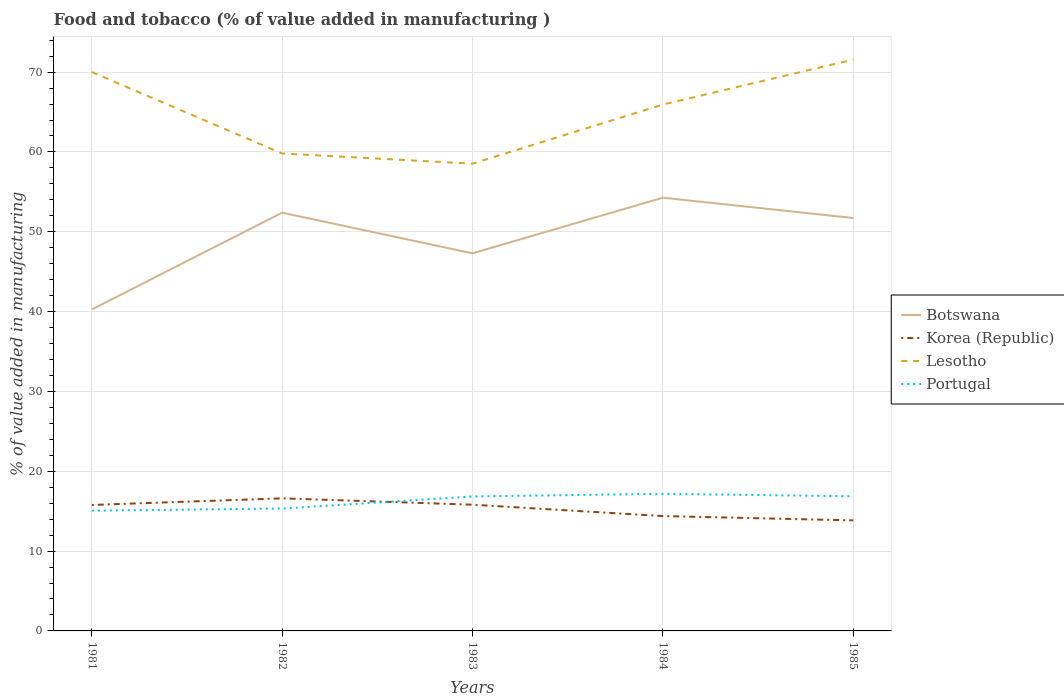Is the number of lines equal to the number of legend labels?
Keep it short and to the point. Yes. Across all years, what is the maximum value added in manufacturing food and tobacco in Portugal?
Offer a very short reply. 15.06. What is the total value added in manufacturing food and tobacco in Korea (Republic) in the graph?
Provide a succinct answer. 2.76. What is the difference between the highest and the second highest value added in manufacturing food and tobacco in Lesotho?
Your answer should be very brief. 13.03. What is the difference between the highest and the lowest value added in manufacturing food and tobacco in Botswana?
Give a very brief answer. 3. Is the value added in manufacturing food and tobacco in Korea (Republic) strictly greater than the value added in manufacturing food and tobacco in Botswana over the years?
Make the answer very short. Yes. Does the graph contain any zero values?
Give a very brief answer. No. Where does the legend appear in the graph?
Give a very brief answer. Center right. How many legend labels are there?
Give a very brief answer. 4. What is the title of the graph?
Make the answer very short. Food and tobacco (% of value added in manufacturing ). What is the label or title of the X-axis?
Keep it short and to the point. Years. What is the label or title of the Y-axis?
Give a very brief answer. % of value added in manufacturing. What is the % of value added in manufacturing of Botswana in 1981?
Provide a short and direct response. 40.27. What is the % of value added in manufacturing in Korea (Republic) in 1981?
Provide a short and direct response. 15.78. What is the % of value added in manufacturing of Lesotho in 1981?
Ensure brevity in your answer.  70.01. What is the % of value added in manufacturing of Portugal in 1981?
Offer a terse response. 15.06. What is the % of value added in manufacturing in Botswana in 1982?
Offer a very short reply. 52.39. What is the % of value added in manufacturing in Korea (Republic) in 1982?
Offer a very short reply. 16.61. What is the % of value added in manufacturing in Lesotho in 1982?
Provide a short and direct response. 59.81. What is the % of value added in manufacturing in Portugal in 1982?
Offer a terse response. 15.33. What is the % of value added in manufacturing of Botswana in 1983?
Keep it short and to the point. 47.3. What is the % of value added in manufacturing of Korea (Republic) in 1983?
Offer a terse response. 15.81. What is the % of value added in manufacturing of Lesotho in 1983?
Give a very brief answer. 58.53. What is the % of value added in manufacturing of Portugal in 1983?
Your answer should be compact. 16.84. What is the % of value added in manufacturing of Botswana in 1984?
Make the answer very short. 54.27. What is the % of value added in manufacturing in Korea (Republic) in 1984?
Provide a short and direct response. 14.39. What is the % of value added in manufacturing in Lesotho in 1984?
Your answer should be very brief. 65.93. What is the % of value added in manufacturing of Portugal in 1984?
Give a very brief answer. 17.17. What is the % of value added in manufacturing of Botswana in 1985?
Make the answer very short. 51.72. What is the % of value added in manufacturing in Korea (Republic) in 1985?
Provide a succinct answer. 13.85. What is the % of value added in manufacturing of Lesotho in 1985?
Provide a succinct answer. 71.56. What is the % of value added in manufacturing of Portugal in 1985?
Make the answer very short. 16.87. Across all years, what is the maximum % of value added in manufacturing in Botswana?
Your response must be concise. 54.27. Across all years, what is the maximum % of value added in manufacturing of Korea (Republic)?
Your response must be concise. 16.61. Across all years, what is the maximum % of value added in manufacturing in Lesotho?
Give a very brief answer. 71.56. Across all years, what is the maximum % of value added in manufacturing in Portugal?
Provide a short and direct response. 17.17. Across all years, what is the minimum % of value added in manufacturing in Botswana?
Provide a succinct answer. 40.27. Across all years, what is the minimum % of value added in manufacturing of Korea (Republic)?
Your answer should be compact. 13.85. Across all years, what is the minimum % of value added in manufacturing of Lesotho?
Provide a short and direct response. 58.53. Across all years, what is the minimum % of value added in manufacturing in Portugal?
Offer a very short reply. 15.06. What is the total % of value added in manufacturing of Botswana in the graph?
Provide a succinct answer. 245.95. What is the total % of value added in manufacturing in Korea (Republic) in the graph?
Provide a short and direct response. 76.43. What is the total % of value added in manufacturing of Lesotho in the graph?
Your response must be concise. 325.84. What is the total % of value added in manufacturing of Portugal in the graph?
Give a very brief answer. 81.27. What is the difference between the % of value added in manufacturing of Botswana in 1981 and that in 1982?
Provide a succinct answer. -12.13. What is the difference between the % of value added in manufacturing of Korea (Republic) in 1981 and that in 1982?
Provide a short and direct response. -0.83. What is the difference between the % of value added in manufacturing of Lesotho in 1981 and that in 1982?
Make the answer very short. 10.2. What is the difference between the % of value added in manufacturing in Portugal in 1981 and that in 1982?
Make the answer very short. -0.27. What is the difference between the % of value added in manufacturing in Botswana in 1981 and that in 1983?
Provide a short and direct response. -7.04. What is the difference between the % of value added in manufacturing in Korea (Republic) in 1981 and that in 1983?
Ensure brevity in your answer.  -0.03. What is the difference between the % of value added in manufacturing of Lesotho in 1981 and that in 1983?
Provide a succinct answer. 11.48. What is the difference between the % of value added in manufacturing of Portugal in 1981 and that in 1983?
Keep it short and to the point. -1.78. What is the difference between the % of value added in manufacturing in Botswana in 1981 and that in 1984?
Offer a terse response. -14. What is the difference between the % of value added in manufacturing of Korea (Republic) in 1981 and that in 1984?
Provide a short and direct response. 1.39. What is the difference between the % of value added in manufacturing in Lesotho in 1981 and that in 1984?
Offer a very short reply. 4.07. What is the difference between the % of value added in manufacturing in Portugal in 1981 and that in 1984?
Offer a very short reply. -2.11. What is the difference between the % of value added in manufacturing of Botswana in 1981 and that in 1985?
Provide a succinct answer. -11.46. What is the difference between the % of value added in manufacturing of Korea (Republic) in 1981 and that in 1985?
Your response must be concise. 1.93. What is the difference between the % of value added in manufacturing in Lesotho in 1981 and that in 1985?
Provide a succinct answer. -1.56. What is the difference between the % of value added in manufacturing in Portugal in 1981 and that in 1985?
Give a very brief answer. -1.81. What is the difference between the % of value added in manufacturing of Botswana in 1982 and that in 1983?
Your answer should be very brief. 5.09. What is the difference between the % of value added in manufacturing of Korea (Republic) in 1982 and that in 1983?
Give a very brief answer. 0.8. What is the difference between the % of value added in manufacturing in Lesotho in 1982 and that in 1983?
Provide a short and direct response. 1.28. What is the difference between the % of value added in manufacturing in Portugal in 1982 and that in 1983?
Your response must be concise. -1.51. What is the difference between the % of value added in manufacturing of Botswana in 1982 and that in 1984?
Make the answer very short. -1.88. What is the difference between the % of value added in manufacturing in Korea (Republic) in 1982 and that in 1984?
Your response must be concise. 2.22. What is the difference between the % of value added in manufacturing in Lesotho in 1982 and that in 1984?
Keep it short and to the point. -6.13. What is the difference between the % of value added in manufacturing of Portugal in 1982 and that in 1984?
Your answer should be very brief. -1.84. What is the difference between the % of value added in manufacturing of Botswana in 1982 and that in 1985?
Offer a terse response. 0.67. What is the difference between the % of value added in manufacturing in Korea (Republic) in 1982 and that in 1985?
Provide a short and direct response. 2.76. What is the difference between the % of value added in manufacturing in Lesotho in 1982 and that in 1985?
Provide a succinct answer. -11.76. What is the difference between the % of value added in manufacturing of Portugal in 1982 and that in 1985?
Provide a short and direct response. -1.54. What is the difference between the % of value added in manufacturing in Botswana in 1983 and that in 1984?
Your answer should be compact. -6.97. What is the difference between the % of value added in manufacturing of Korea (Republic) in 1983 and that in 1984?
Offer a very short reply. 1.43. What is the difference between the % of value added in manufacturing of Lesotho in 1983 and that in 1984?
Offer a terse response. -7.4. What is the difference between the % of value added in manufacturing of Portugal in 1983 and that in 1984?
Offer a very short reply. -0.33. What is the difference between the % of value added in manufacturing in Botswana in 1983 and that in 1985?
Offer a terse response. -4.42. What is the difference between the % of value added in manufacturing in Korea (Republic) in 1983 and that in 1985?
Your answer should be compact. 1.97. What is the difference between the % of value added in manufacturing of Lesotho in 1983 and that in 1985?
Offer a very short reply. -13.03. What is the difference between the % of value added in manufacturing in Portugal in 1983 and that in 1985?
Give a very brief answer. -0.02. What is the difference between the % of value added in manufacturing of Botswana in 1984 and that in 1985?
Keep it short and to the point. 2.54. What is the difference between the % of value added in manufacturing of Korea (Republic) in 1984 and that in 1985?
Provide a succinct answer. 0.54. What is the difference between the % of value added in manufacturing in Lesotho in 1984 and that in 1985?
Offer a terse response. -5.63. What is the difference between the % of value added in manufacturing in Portugal in 1984 and that in 1985?
Give a very brief answer. 0.31. What is the difference between the % of value added in manufacturing in Botswana in 1981 and the % of value added in manufacturing in Korea (Republic) in 1982?
Your response must be concise. 23.66. What is the difference between the % of value added in manufacturing of Botswana in 1981 and the % of value added in manufacturing of Lesotho in 1982?
Offer a very short reply. -19.54. What is the difference between the % of value added in manufacturing of Botswana in 1981 and the % of value added in manufacturing of Portugal in 1982?
Make the answer very short. 24.94. What is the difference between the % of value added in manufacturing of Korea (Republic) in 1981 and the % of value added in manufacturing of Lesotho in 1982?
Keep it short and to the point. -44.03. What is the difference between the % of value added in manufacturing in Korea (Republic) in 1981 and the % of value added in manufacturing in Portugal in 1982?
Keep it short and to the point. 0.45. What is the difference between the % of value added in manufacturing in Lesotho in 1981 and the % of value added in manufacturing in Portugal in 1982?
Ensure brevity in your answer.  54.68. What is the difference between the % of value added in manufacturing in Botswana in 1981 and the % of value added in manufacturing in Korea (Republic) in 1983?
Give a very brief answer. 24.45. What is the difference between the % of value added in manufacturing in Botswana in 1981 and the % of value added in manufacturing in Lesotho in 1983?
Make the answer very short. -18.26. What is the difference between the % of value added in manufacturing in Botswana in 1981 and the % of value added in manufacturing in Portugal in 1983?
Provide a short and direct response. 23.42. What is the difference between the % of value added in manufacturing in Korea (Republic) in 1981 and the % of value added in manufacturing in Lesotho in 1983?
Provide a succinct answer. -42.75. What is the difference between the % of value added in manufacturing of Korea (Republic) in 1981 and the % of value added in manufacturing of Portugal in 1983?
Your answer should be compact. -1.07. What is the difference between the % of value added in manufacturing of Lesotho in 1981 and the % of value added in manufacturing of Portugal in 1983?
Ensure brevity in your answer.  53.16. What is the difference between the % of value added in manufacturing of Botswana in 1981 and the % of value added in manufacturing of Korea (Republic) in 1984?
Ensure brevity in your answer.  25.88. What is the difference between the % of value added in manufacturing in Botswana in 1981 and the % of value added in manufacturing in Lesotho in 1984?
Provide a succinct answer. -25.67. What is the difference between the % of value added in manufacturing of Botswana in 1981 and the % of value added in manufacturing of Portugal in 1984?
Offer a terse response. 23.09. What is the difference between the % of value added in manufacturing in Korea (Republic) in 1981 and the % of value added in manufacturing in Lesotho in 1984?
Your answer should be very brief. -50.16. What is the difference between the % of value added in manufacturing in Korea (Republic) in 1981 and the % of value added in manufacturing in Portugal in 1984?
Provide a succinct answer. -1.4. What is the difference between the % of value added in manufacturing of Lesotho in 1981 and the % of value added in manufacturing of Portugal in 1984?
Provide a short and direct response. 52.83. What is the difference between the % of value added in manufacturing in Botswana in 1981 and the % of value added in manufacturing in Korea (Republic) in 1985?
Your response must be concise. 26.42. What is the difference between the % of value added in manufacturing in Botswana in 1981 and the % of value added in manufacturing in Lesotho in 1985?
Keep it short and to the point. -31.3. What is the difference between the % of value added in manufacturing of Botswana in 1981 and the % of value added in manufacturing of Portugal in 1985?
Provide a short and direct response. 23.4. What is the difference between the % of value added in manufacturing of Korea (Republic) in 1981 and the % of value added in manufacturing of Lesotho in 1985?
Offer a terse response. -55.79. What is the difference between the % of value added in manufacturing of Korea (Republic) in 1981 and the % of value added in manufacturing of Portugal in 1985?
Keep it short and to the point. -1.09. What is the difference between the % of value added in manufacturing in Lesotho in 1981 and the % of value added in manufacturing in Portugal in 1985?
Provide a short and direct response. 53.14. What is the difference between the % of value added in manufacturing of Botswana in 1982 and the % of value added in manufacturing of Korea (Republic) in 1983?
Offer a very short reply. 36.58. What is the difference between the % of value added in manufacturing of Botswana in 1982 and the % of value added in manufacturing of Lesotho in 1983?
Your response must be concise. -6.14. What is the difference between the % of value added in manufacturing in Botswana in 1982 and the % of value added in manufacturing in Portugal in 1983?
Ensure brevity in your answer.  35.55. What is the difference between the % of value added in manufacturing in Korea (Republic) in 1982 and the % of value added in manufacturing in Lesotho in 1983?
Offer a terse response. -41.92. What is the difference between the % of value added in manufacturing of Korea (Republic) in 1982 and the % of value added in manufacturing of Portugal in 1983?
Give a very brief answer. -0.23. What is the difference between the % of value added in manufacturing in Lesotho in 1982 and the % of value added in manufacturing in Portugal in 1983?
Keep it short and to the point. 42.96. What is the difference between the % of value added in manufacturing of Botswana in 1982 and the % of value added in manufacturing of Korea (Republic) in 1984?
Provide a succinct answer. 38.01. What is the difference between the % of value added in manufacturing of Botswana in 1982 and the % of value added in manufacturing of Lesotho in 1984?
Provide a succinct answer. -13.54. What is the difference between the % of value added in manufacturing of Botswana in 1982 and the % of value added in manufacturing of Portugal in 1984?
Offer a terse response. 35.22. What is the difference between the % of value added in manufacturing in Korea (Republic) in 1982 and the % of value added in manufacturing in Lesotho in 1984?
Your answer should be compact. -49.32. What is the difference between the % of value added in manufacturing of Korea (Republic) in 1982 and the % of value added in manufacturing of Portugal in 1984?
Provide a succinct answer. -0.56. What is the difference between the % of value added in manufacturing in Lesotho in 1982 and the % of value added in manufacturing in Portugal in 1984?
Your answer should be very brief. 42.63. What is the difference between the % of value added in manufacturing of Botswana in 1982 and the % of value added in manufacturing of Korea (Republic) in 1985?
Your response must be concise. 38.55. What is the difference between the % of value added in manufacturing of Botswana in 1982 and the % of value added in manufacturing of Lesotho in 1985?
Make the answer very short. -19.17. What is the difference between the % of value added in manufacturing of Botswana in 1982 and the % of value added in manufacturing of Portugal in 1985?
Keep it short and to the point. 35.53. What is the difference between the % of value added in manufacturing in Korea (Republic) in 1982 and the % of value added in manufacturing in Lesotho in 1985?
Provide a succinct answer. -54.95. What is the difference between the % of value added in manufacturing in Korea (Republic) in 1982 and the % of value added in manufacturing in Portugal in 1985?
Make the answer very short. -0.26. What is the difference between the % of value added in manufacturing in Lesotho in 1982 and the % of value added in manufacturing in Portugal in 1985?
Ensure brevity in your answer.  42.94. What is the difference between the % of value added in manufacturing in Botswana in 1983 and the % of value added in manufacturing in Korea (Republic) in 1984?
Ensure brevity in your answer.  32.91. What is the difference between the % of value added in manufacturing of Botswana in 1983 and the % of value added in manufacturing of Lesotho in 1984?
Your answer should be very brief. -18.63. What is the difference between the % of value added in manufacturing of Botswana in 1983 and the % of value added in manufacturing of Portugal in 1984?
Your answer should be compact. 30.13. What is the difference between the % of value added in manufacturing of Korea (Republic) in 1983 and the % of value added in manufacturing of Lesotho in 1984?
Keep it short and to the point. -50.12. What is the difference between the % of value added in manufacturing of Korea (Republic) in 1983 and the % of value added in manufacturing of Portugal in 1984?
Make the answer very short. -1.36. What is the difference between the % of value added in manufacturing of Lesotho in 1983 and the % of value added in manufacturing of Portugal in 1984?
Ensure brevity in your answer.  41.36. What is the difference between the % of value added in manufacturing in Botswana in 1983 and the % of value added in manufacturing in Korea (Republic) in 1985?
Offer a very short reply. 33.46. What is the difference between the % of value added in manufacturing in Botswana in 1983 and the % of value added in manufacturing in Lesotho in 1985?
Provide a succinct answer. -24.26. What is the difference between the % of value added in manufacturing in Botswana in 1983 and the % of value added in manufacturing in Portugal in 1985?
Offer a terse response. 30.43. What is the difference between the % of value added in manufacturing of Korea (Republic) in 1983 and the % of value added in manufacturing of Lesotho in 1985?
Give a very brief answer. -55.75. What is the difference between the % of value added in manufacturing in Korea (Republic) in 1983 and the % of value added in manufacturing in Portugal in 1985?
Provide a short and direct response. -1.05. What is the difference between the % of value added in manufacturing of Lesotho in 1983 and the % of value added in manufacturing of Portugal in 1985?
Ensure brevity in your answer.  41.66. What is the difference between the % of value added in manufacturing in Botswana in 1984 and the % of value added in manufacturing in Korea (Republic) in 1985?
Keep it short and to the point. 40.42. What is the difference between the % of value added in manufacturing in Botswana in 1984 and the % of value added in manufacturing in Lesotho in 1985?
Your answer should be compact. -17.3. What is the difference between the % of value added in manufacturing of Botswana in 1984 and the % of value added in manufacturing of Portugal in 1985?
Provide a succinct answer. 37.4. What is the difference between the % of value added in manufacturing in Korea (Republic) in 1984 and the % of value added in manufacturing in Lesotho in 1985?
Your answer should be very brief. -57.18. What is the difference between the % of value added in manufacturing in Korea (Republic) in 1984 and the % of value added in manufacturing in Portugal in 1985?
Provide a short and direct response. -2.48. What is the difference between the % of value added in manufacturing of Lesotho in 1984 and the % of value added in manufacturing of Portugal in 1985?
Keep it short and to the point. 49.07. What is the average % of value added in manufacturing of Botswana per year?
Your answer should be very brief. 49.19. What is the average % of value added in manufacturing in Korea (Republic) per year?
Give a very brief answer. 15.29. What is the average % of value added in manufacturing of Lesotho per year?
Your answer should be compact. 65.17. What is the average % of value added in manufacturing in Portugal per year?
Offer a very short reply. 16.25. In the year 1981, what is the difference between the % of value added in manufacturing in Botswana and % of value added in manufacturing in Korea (Republic)?
Provide a succinct answer. 24.49. In the year 1981, what is the difference between the % of value added in manufacturing of Botswana and % of value added in manufacturing of Lesotho?
Your response must be concise. -29.74. In the year 1981, what is the difference between the % of value added in manufacturing in Botswana and % of value added in manufacturing in Portugal?
Ensure brevity in your answer.  25.21. In the year 1981, what is the difference between the % of value added in manufacturing of Korea (Republic) and % of value added in manufacturing of Lesotho?
Make the answer very short. -54.23. In the year 1981, what is the difference between the % of value added in manufacturing in Korea (Republic) and % of value added in manufacturing in Portugal?
Provide a succinct answer. 0.72. In the year 1981, what is the difference between the % of value added in manufacturing of Lesotho and % of value added in manufacturing of Portugal?
Give a very brief answer. 54.95. In the year 1982, what is the difference between the % of value added in manufacturing in Botswana and % of value added in manufacturing in Korea (Republic)?
Offer a terse response. 35.78. In the year 1982, what is the difference between the % of value added in manufacturing of Botswana and % of value added in manufacturing of Lesotho?
Make the answer very short. -7.41. In the year 1982, what is the difference between the % of value added in manufacturing of Botswana and % of value added in manufacturing of Portugal?
Ensure brevity in your answer.  37.06. In the year 1982, what is the difference between the % of value added in manufacturing of Korea (Republic) and % of value added in manufacturing of Lesotho?
Your response must be concise. -43.2. In the year 1982, what is the difference between the % of value added in manufacturing in Korea (Republic) and % of value added in manufacturing in Portugal?
Make the answer very short. 1.28. In the year 1982, what is the difference between the % of value added in manufacturing of Lesotho and % of value added in manufacturing of Portugal?
Offer a terse response. 44.48. In the year 1983, what is the difference between the % of value added in manufacturing of Botswana and % of value added in manufacturing of Korea (Republic)?
Make the answer very short. 31.49. In the year 1983, what is the difference between the % of value added in manufacturing in Botswana and % of value added in manufacturing in Lesotho?
Give a very brief answer. -11.23. In the year 1983, what is the difference between the % of value added in manufacturing of Botswana and % of value added in manufacturing of Portugal?
Offer a very short reply. 30.46. In the year 1983, what is the difference between the % of value added in manufacturing in Korea (Republic) and % of value added in manufacturing in Lesotho?
Offer a very short reply. -42.72. In the year 1983, what is the difference between the % of value added in manufacturing in Korea (Republic) and % of value added in manufacturing in Portugal?
Keep it short and to the point. -1.03. In the year 1983, what is the difference between the % of value added in manufacturing in Lesotho and % of value added in manufacturing in Portugal?
Make the answer very short. 41.69. In the year 1984, what is the difference between the % of value added in manufacturing in Botswana and % of value added in manufacturing in Korea (Republic)?
Provide a short and direct response. 39.88. In the year 1984, what is the difference between the % of value added in manufacturing in Botswana and % of value added in manufacturing in Lesotho?
Your answer should be compact. -11.67. In the year 1984, what is the difference between the % of value added in manufacturing of Botswana and % of value added in manufacturing of Portugal?
Ensure brevity in your answer.  37.09. In the year 1984, what is the difference between the % of value added in manufacturing in Korea (Republic) and % of value added in manufacturing in Lesotho?
Your answer should be compact. -51.55. In the year 1984, what is the difference between the % of value added in manufacturing of Korea (Republic) and % of value added in manufacturing of Portugal?
Ensure brevity in your answer.  -2.79. In the year 1984, what is the difference between the % of value added in manufacturing of Lesotho and % of value added in manufacturing of Portugal?
Keep it short and to the point. 48.76. In the year 1985, what is the difference between the % of value added in manufacturing of Botswana and % of value added in manufacturing of Korea (Republic)?
Offer a terse response. 37.88. In the year 1985, what is the difference between the % of value added in manufacturing of Botswana and % of value added in manufacturing of Lesotho?
Make the answer very short. -19.84. In the year 1985, what is the difference between the % of value added in manufacturing in Botswana and % of value added in manufacturing in Portugal?
Ensure brevity in your answer.  34.86. In the year 1985, what is the difference between the % of value added in manufacturing of Korea (Republic) and % of value added in manufacturing of Lesotho?
Give a very brief answer. -57.72. In the year 1985, what is the difference between the % of value added in manufacturing of Korea (Republic) and % of value added in manufacturing of Portugal?
Your response must be concise. -3.02. In the year 1985, what is the difference between the % of value added in manufacturing of Lesotho and % of value added in manufacturing of Portugal?
Give a very brief answer. 54.7. What is the ratio of the % of value added in manufacturing in Botswana in 1981 to that in 1982?
Ensure brevity in your answer.  0.77. What is the ratio of the % of value added in manufacturing in Korea (Republic) in 1981 to that in 1982?
Ensure brevity in your answer.  0.95. What is the ratio of the % of value added in manufacturing in Lesotho in 1981 to that in 1982?
Your answer should be compact. 1.17. What is the ratio of the % of value added in manufacturing of Portugal in 1981 to that in 1982?
Offer a very short reply. 0.98. What is the ratio of the % of value added in manufacturing in Botswana in 1981 to that in 1983?
Ensure brevity in your answer.  0.85. What is the ratio of the % of value added in manufacturing of Korea (Republic) in 1981 to that in 1983?
Ensure brevity in your answer.  1. What is the ratio of the % of value added in manufacturing in Lesotho in 1981 to that in 1983?
Make the answer very short. 1.2. What is the ratio of the % of value added in manufacturing in Portugal in 1981 to that in 1983?
Make the answer very short. 0.89. What is the ratio of the % of value added in manufacturing in Botswana in 1981 to that in 1984?
Offer a very short reply. 0.74. What is the ratio of the % of value added in manufacturing in Korea (Republic) in 1981 to that in 1984?
Make the answer very short. 1.1. What is the ratio of the % of value added in manufacturing in Lesotho in 1981 to that in 1984?
Provide a succinct answer. 1.06. What is the ratio of the % of value added in manufacturing of Portugal in 1981 to that in 1984?
Your response must be concise. 0.88. What is the ratio of the % of value added in manufacturing in Botswana in 1981 to that in 1985?
Make the answer very short. 0.78. What is the ratio of the % of value added in manufacturing in Korea (Republic) in 1981 to that in 1985?
Offer a terse response. 1.14. What is the ratio of the % of value added in manufacturing of Lesotho in 1981 to that in 1985?
Offer a terse response. 0.98. What is the ratio of the % of value added in manufacturing of Portugal in 1981 to that in 1985?
Your answer should be very brief. 0.89. What is the ratio of the % of value added in manufacturing of Botswana in 1982 to that in 1983?
Your answer should be compact. 1.11. What is the ratio of the % of value added in manufacturing of Korea (Republic) in 1982 to that in 1983?
Make the answer very short. 1.05. What is the ratio of the % of value added in manufacturing of Lesotho in 1982 to that in 1983?
Give a very brief answer. 1.02. What is the ratio of the % of value added in manufacturing of Portugal in 1982 to that in 1983?
Give a very brief answer. 0.91. What is the ratio of the % of value added in manufacturing of Botswana in 1982 to that in 1984?
Give a very brief answer. 0.97. What is the ratio of the % of value added in manufacturing of Korea (Republic) in 1982 to that in 1984?
Make the answer very short. 1.15. What is the ratio of the % of value added in manufacturing in Lesotho in 1982 to that in 1984?
Give a very brief answer. 0.91. What is the ratio of the % of value added in manufacturing of Portugal in 1982 to that in 1984?
Give a very brief answer. 0.89. What is the ratio of the % of value added in manufacturing of Botswana in 1982 to that in 1985?
Make the answer very short. 1.01. What is the ratio of the % of value added in manufacturing of Korea (Republic) in 1982 to that in 1985?
Give a very brief answer. 1.2. What is the ratio of the % of value added in manufacturing of Lesotho in 1982 to that in 1985?
Your answer should be compact. 0.84. What is the ratio of the % of value added in manufacturing of Portugal in 1982 to that in 1985?
Your response must be concise. 0.91. What is the ratio of the % of value added in manufacturing of Botswana in 1983 to that in 1984?
Ensure brevity in your answer.  0.87. What is the ratio of the % of value added in manufacturing in Korea (Republic) in 1983 to that in 1984?
Give a very brief answer. 1.1. What is the ratio of the % of value added in manufacturing in Lesotho in 1983 to that in 1984?
Provide a short and direct response. 0.89. What is the ratio of the % of value added in manufacturing of Portugal in 1983 to that in 1984?
Give a very brief answer. 0.98. What is the ratio of the % of value added in manufacturing in Botswana in 1983 to that in 1985?
Give a very brief answer. 0.91. What is the ratio of the % of value added in manufacturing of Korea (Republic) in 1983 to that in 1985?
Ensure brevity in your answer.  1.14. What is the ratio of the % of value added in manufacturing in Lesotho in 1983 to that in 1985?
Ensure brevity in your answer.  0.82. What is the ratio of the % of value added in manufacturing of Botswana in 1984 to that in 1985?
Your answer should be compact. 1.05. What is the ratio of the % of value added in manufacturing of Korea (Republic) in 1984 to that in 1985?
Provide a short and direct response. 1.04. What is the ratio of the % of value added in manufacturing of Lesotho in 1984 to that in 1985?
Provide a succinct answer. 0.92. What is the ratio of the % of value added in manufacturing in Portugal in 1984 to that in 1985?
Your answer should be compact. 1.02. What is the difference between the highest and the second highest % of value added in manufacturing in Botswana?
Give a very brief answer. 1.88. What is the difference between the highest and the second highest % of value added in manufacturing in Korea (Republic)?
Provide a succinct answer. 0.8. What is the difference between the highest and the second highest % of value added in manufacturing of Lesotho?
Make the answer very short. 1.56. What is the difference between the highest and the second highest % of value added in manufacturing of Portugal?
Your answer should be compact. 0.31. What is the difference between the highest and the lowest % of value added in manufacturing in Botswana?
Keep it short and to the point. 14. What is the difference between the highest and the lowest % of value added in manufacturing of Korea (Republic)?
Give a very brief answer. 2.76. What is the difference between the highest and the lowest % of value added in manufacturing in Lesotho?
Offer a very short reply. 13.03. What is the difference between the highest and the lowest % of value added in manufacturing of Portugal?
Keep it short and to the point. 2.11. 